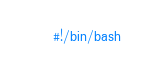Convert code to text. <code><loc_0><loc_0><loc_500><loc_500><_Bash_>#!/bin/bash</code> 